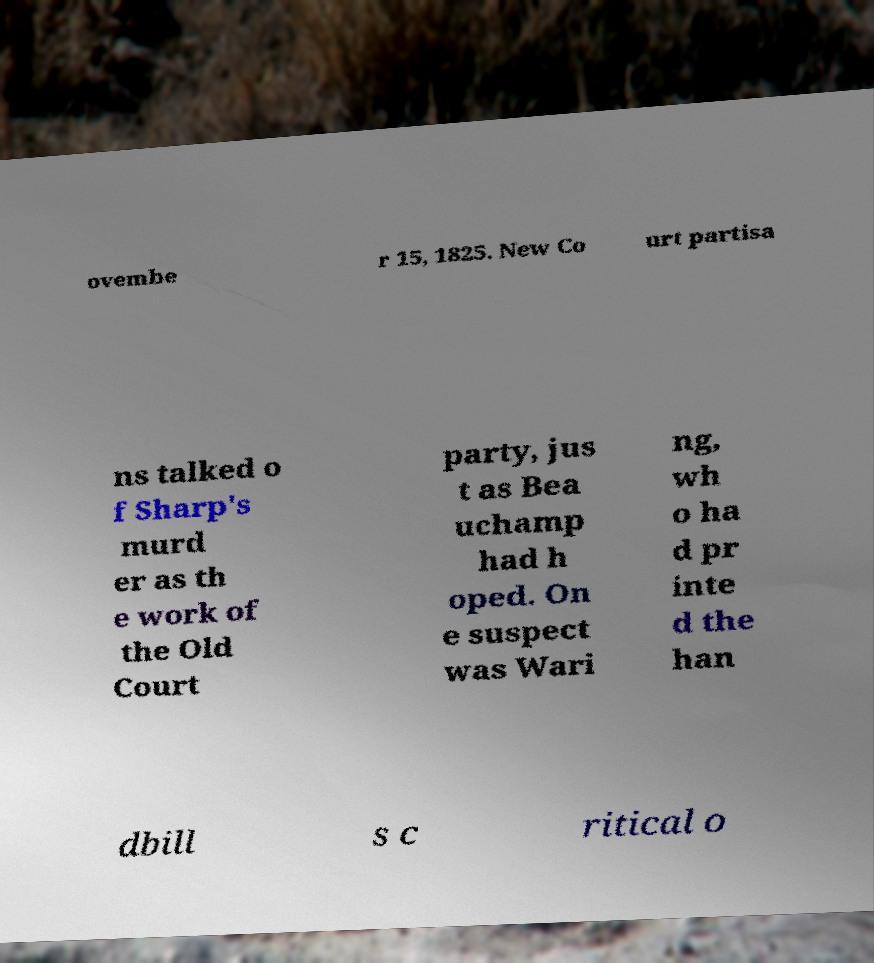Could you assist in decoding the text presented in this image and type it out clearly? ovembe r 15, 1825. New Co urt partisa ns talked o f Sharp's murd er as th e work of the Old Court party, jus t as Bea uchamp had h oped. On e suspect was Wari ng, wh o ha d pr inte d the han dbill s c ritical o 